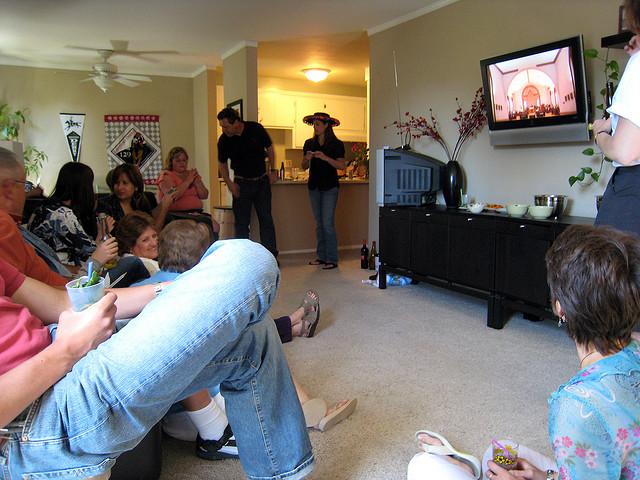What room are they in?
Keep it brief. Living room. Is the tv on?
Write a very short answer. Yes. Is there a party going on?
Short answer required. Yes. 